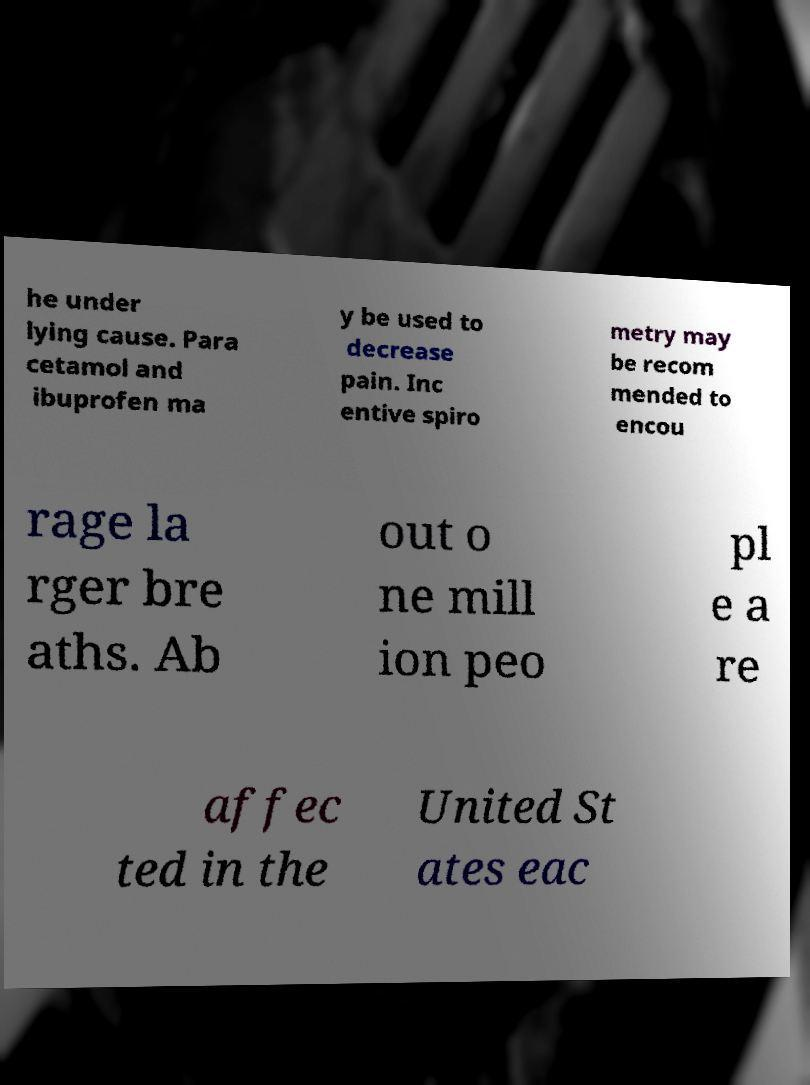Could you assist in decoding the text presented in this image and type it out clearly? he under lying cause. Para cetamol and ibuprofen ma y be used to decrease pain. Inc entive spiro metry may be recom mended to encou rage la rger bre aths. Ab out o ne mill ion peo pl e a re affec ted in the United St ates eac 